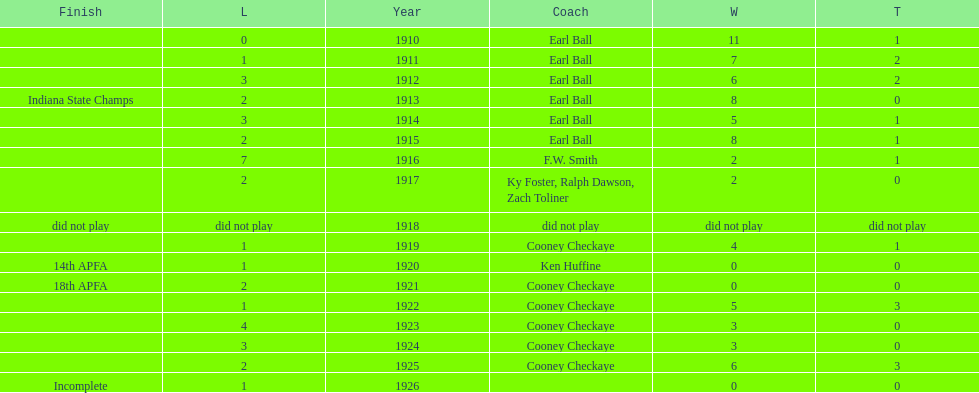The muncie flyers played from 1910 to 1925 in all but one of those years. which year did the flyers not play? 1918. 